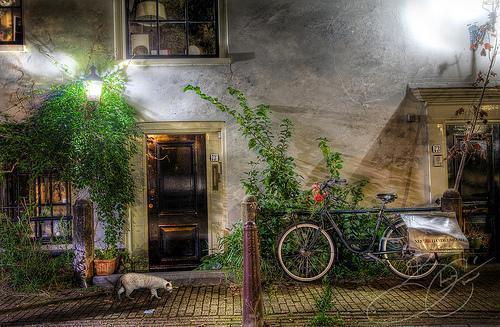How many cats are there?
Give a very brief answer. 1. 